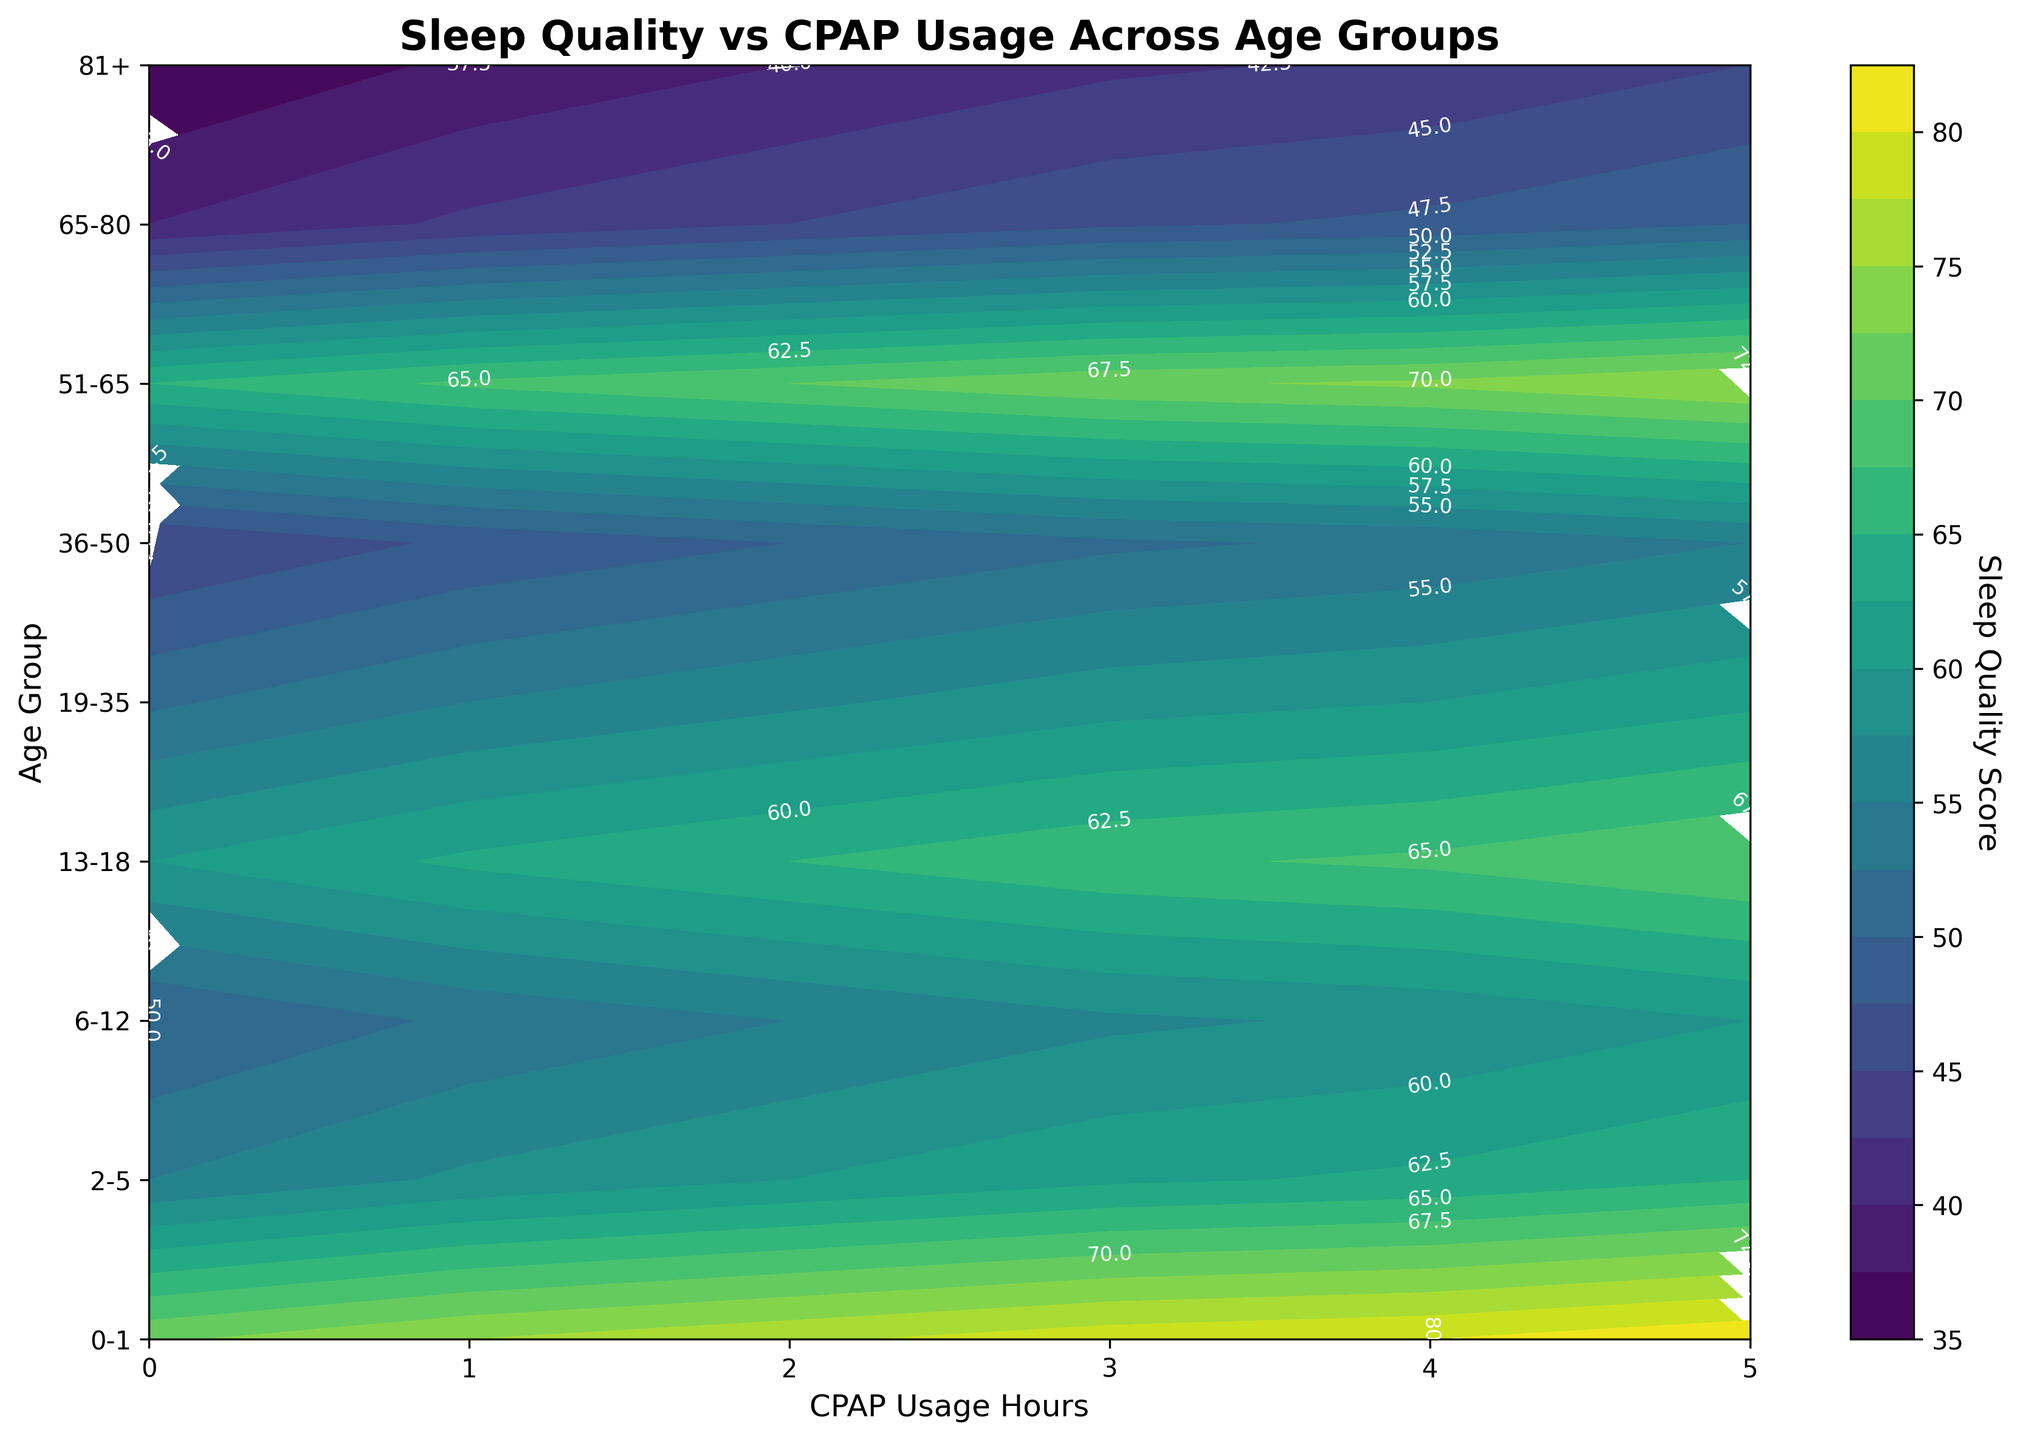What does the title of the figure say? The title of the figure is usually located at the top and describes what the plot is about. Here, it reads "Sleep Quality vs CPAP Usage Across Age Groups".
Answer: Sleep Quality vs CPAP Usage Across Age Groups What are the two axes labelled as? By observing the sides of the plot, the horizontal axis is labelled 'CPAP Usage Hours' and the vertical axis is labelled 'Age Group'.
Answer: CPAP Usage Hours and Age Group Which age group shows the highest sleep quality score without using a CPAP machine? To find this, look at the lowest CPAP Usage Hours (0) on the horizontal axis and compare the Sleep Quality Scores across different Age Groups. The Age Group '0-1' has the highest Sleep Quality Score.
Answer: 0-1 How does the sleep quality score change as CPAP usage increases for the age group 51-65? Track the contour lines across the CPAP Usage Hours for the age group 51-65. The Sleep Quality Score starts at 45 and gradually increases to 55 as CPAP usage reaches the highest value.
Answer: It increases from 45 to 55 Compare the sleep quality scores between the age groups 19-35 and 65-80 at 4 hours of CPAP usage. Which age group has a higher sleep quality score? Find the position where CPAP Usage Hours is 4, then compare Sleep Quality Scores for Age Groups 19-35 and 65-80. The 19-35 group shows a score of 58, while the 65-80 group shows a score of 48.
Answer: 19-35 Which age group exhibits the most significant improvement in sleep quality score from zero to full CPAP usage? To determine this, look at the difference between the Sleep Quality Score at 0 and 5 Hours of CPAP Usage for each Age Group. The age group '0-1' shows an improvement from 72 to 82 — the largest difference (10 points).
Answer: 0-1 Identify the age group with the lowest sleep quality score at 5 hours of CPAP usage. What is that score? Find the maximum CPAP Usage Hours (5) and check the Sleep Quality Scores across all Age Groups. The age group '81+' shows the lowest score of 45.
Answer: 81+ and 45 At what CPAP usage hour does the age group 0-1 reach a sleep quality score of approximately 80? Locate the contour line or value nearest to 80 for the Age Group '0-1'. It intersects at around 4 hours of CPAP usage.
Answer: 4 hours What is the average sleep quality score for the age group 36-50 across all CPAP usage hours? To determine the average, add up the Sleep Quality Scores for all CPAP Usage Hours (52, 55, 57, 59, 60, 62) and divide by the number of usage hours (6). The calculation is (52+55+57+59+60+62)/6 = 57.5.
Answer: 57.5 Compare the contours of age group 6-12 and 13-18 in terms of sleep quality improvement from 0 to 3 hours of CPAP usage. Which age group shows a higher increase in score? For 6-12, the score goes from 65 to 72 (7 points increase). For 13-18, the score goes from 55 to 62 (7 points increase). Both age groups show an equal increase of 7 points.
Answer: Both show an equal increase 